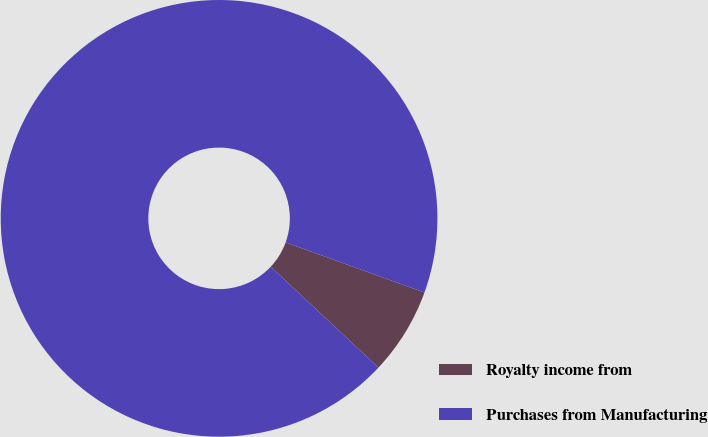<chart> <loc_0><loc_0><loc_500><loc_500><pie_chart><fcel>Royalty income from<fcel>Purchases from Manufacturing<nl><fcel>6.46%<fcel>93.54%<nl></chart> 